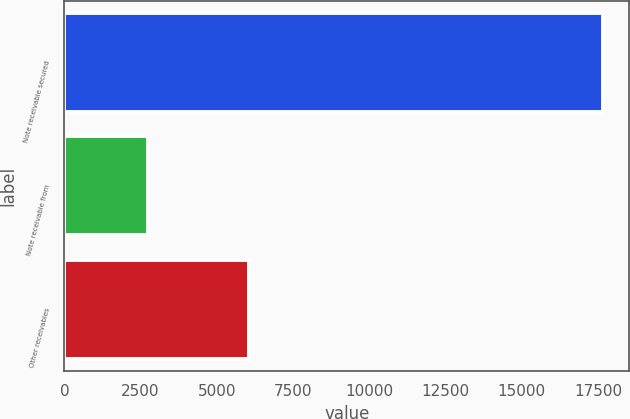<chart> <loc_0><loc_0><loc_500><loc_500><bar_chart><fcel>Note receivable secured<fcel>Note receivable from<fcel>Other receivables<nl><fcel>17646<fcel>2734<fcel>6069<nl></chart> 